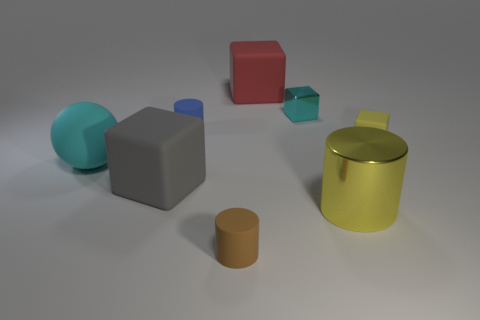Which objects in the image could be associated with geometry lessons and why? In the context of geometry lessons, one could focus on the various distinct shapes present in the image. You have clear examples of a sphere, cube, and cylinder. Discussing their properties, like the sphere’s lack of edges and vertices or the cube's equal sides and right angles, would provide excellent practical examples for such a lesson. 